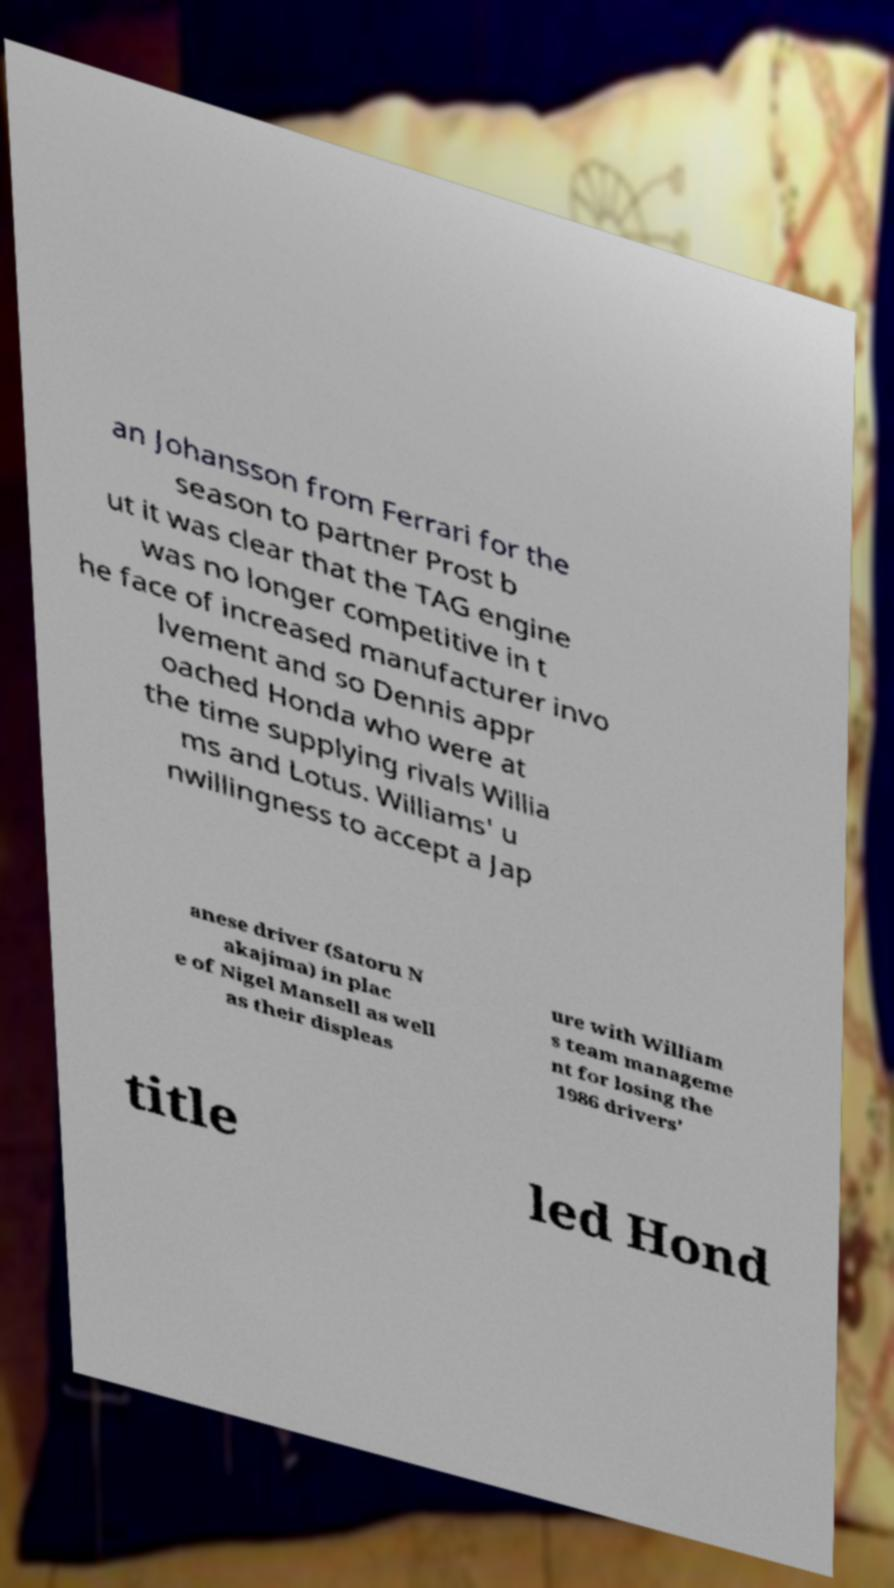Please read and relay the text visible in this image. What does it say? an Johansson from Ferrari for the season to partner Prost b ut it was clear that the TAG engine was no longer competitive in t he face of increased manufacturer invo lvement and so Dennis appr oached Honda who were at the time supplying rivals Willia ms and Lotus. Williams' u nwillingness to accept a Jap anese driver (Satoru N akajima) in plac e of Nigel Mansell as well as their displeas ure with William s team manageme nt for losing the 1986 drivers' title led Hond 